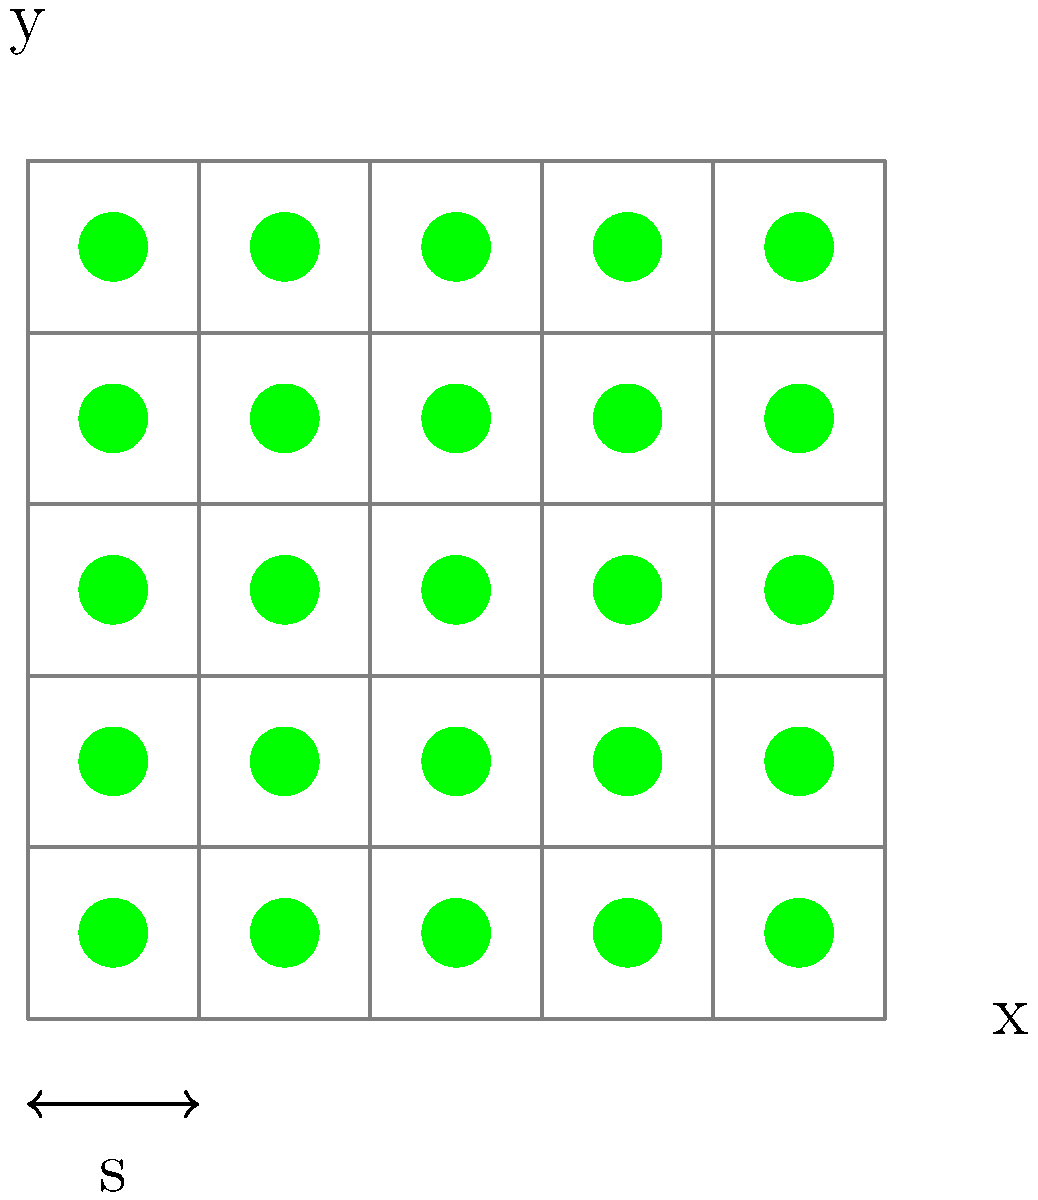A sustainable cannabis farm uses a grid layout for planting, as shown in the diagram. The spacing between plants is represented by $s$ meters. If the total area of the farm is 400 square meters and the optimal yield is achieved when there are 100 plants in total, what is the optimal spacing $s$ between plants? Let's approach this step-by-step:

1) First, we need to understand the relationship between the number of plants, spacing, and total area.

2) If we have a square grid with $n$ plants on each side, the total number of plants is $n^2$.

3) Given that there are 100 plants in total, we can say:
   $n^2 = 100$
   $n = 10$

4) This means we have a 10x10 grid of plants.

5) Now, let's consider the area. If the spacing between plants is $s$ meters, the length of one side of the farm is $10s$ meters (9 spaces between 10 plants, plus half a space on each end).

6) The total area is given as 400 square meters. We can express this as:
   $(10s)^2 = 400$

7) Solving this equation:
   $100s^2 = 400$
   $s^2 = 4$
   $s = 2$

8) Therefore, the optimal spacing between plants is 2 meters.
Answer: 2 meters 